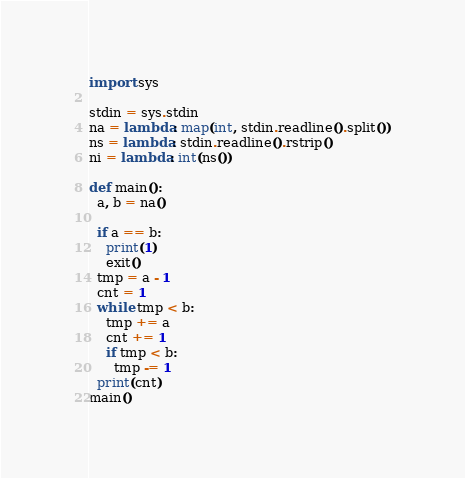<code> <loc_0><loc_0><loc_500><loc_500><_Python_>import sys

stdin = sys.stdin
na = lambda: map(int, stdin.readline().split())
ns = lambda: stdin.readline().rstrip()
ni = lambda: int(ns())

def main():
  a, b = na()

  if a == b:
    print(1)
    exit()
  tmp = a - 1
  cnt = 1
  while tmp < b:
    tmp += a
    cnt += 1
    if tmp < b:
      tmp -= 1
  print(cnt)
main()</code> 